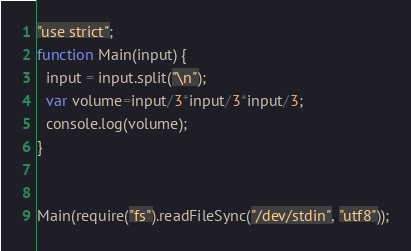Convert code to text. <code><loc_0><loc_0><loc_500><loc_500><_JavaScript_>"use strict";
function Main(input) {
  input = input.split("\n");
  var volume=input/3*input/3*input/3;
  console.log(volume);
}


Main(require("fs").readFileSync("/dev/stdin", "utf8"));</code> 